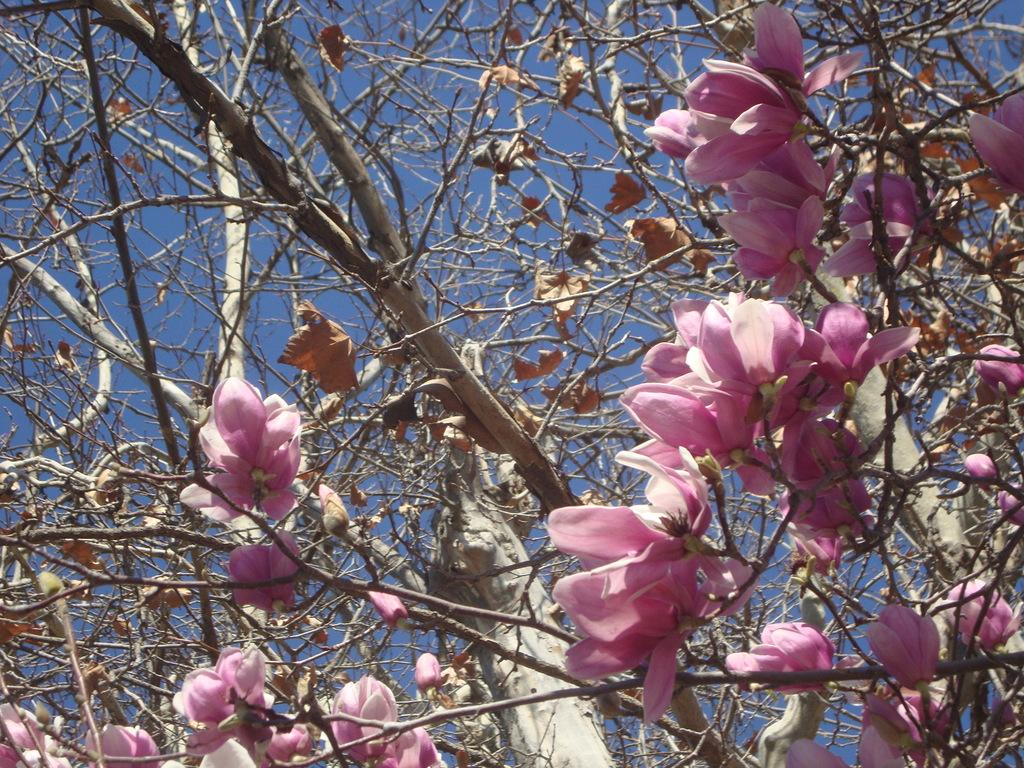What type of vegetation can be seen in the image? There are trees in the image. What are the trees in the image displaying? The trees have flowers. What color are the flowers on the trees? The flowers are pink in color. Are there any grains visible in the image? There is no mention of grains in the provided facts, so we cannot determine if any are present in the image. 